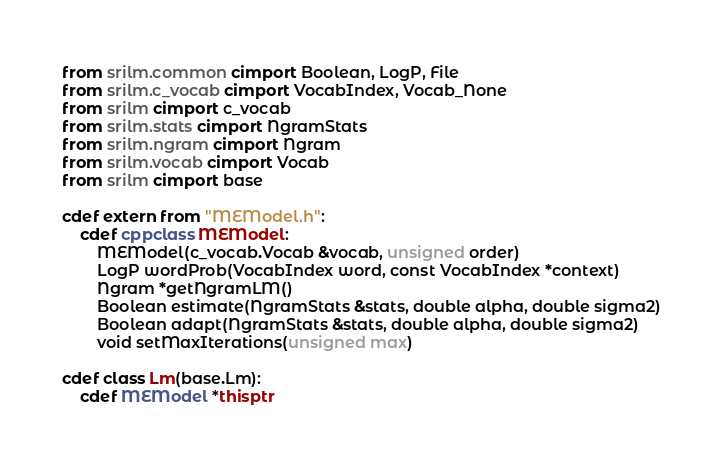Convert code to text. <code><loc_0><loc_0><loc_500><loc_500><_Cython_>from srilm.common cimport Boolean, LogP, File
from srilm.c_vocab cimport VocabIndex, Vocab_None
from srilm cimport c_vocab
from srilm.stats cimport NgramStats
from srilm.ngram cimport Ngram
from srilm.vocab cimport Vocab
from srilm cimport base

cdef extern from "MEModel.h":
    cdef cppclass MEModel:
        MEModel(c_vocab.Vocab &vocab, unsigned order)
        LogP wordProb(VocabIndex word, const VocabIndex *context)
        Ngram *getNgramLM()
        Boolean estimate(NgramStats &stats, double alpha, double sigma2)
        Boolean adapt(NgramStats &stats, double alpha, double sigma2)
        void setMaxIterations(unsigned max)

cdef class Lm(base.Lm):
    cdef MEModel *thisptr

</code> 